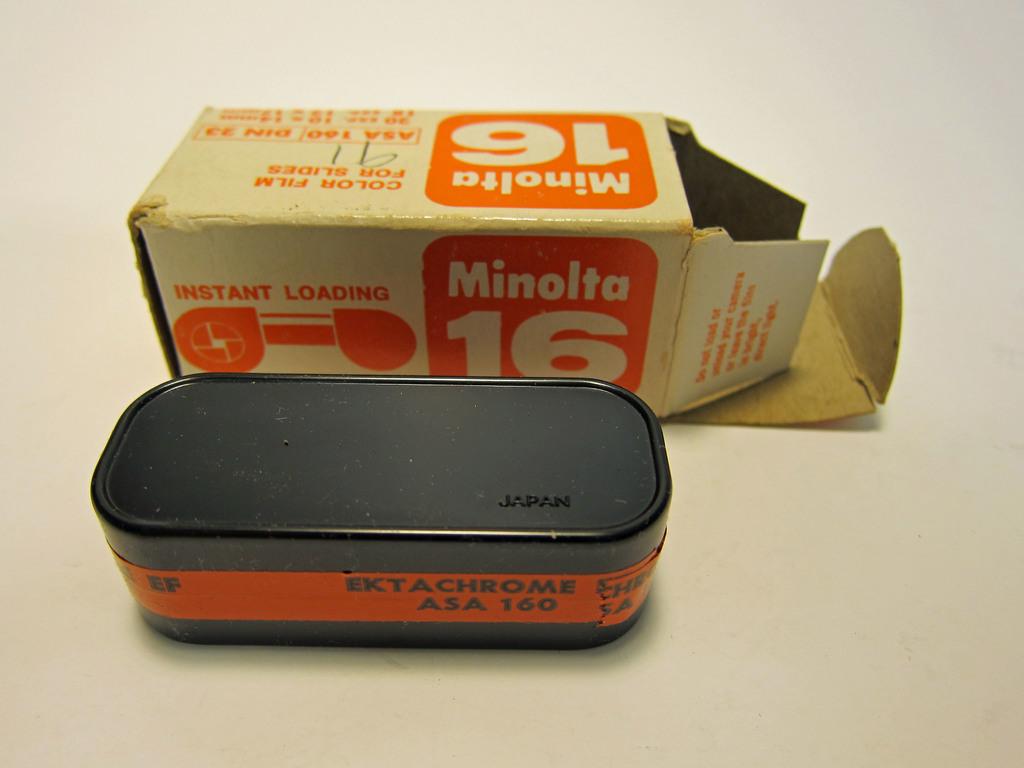What brand of camera is this?
Offer a very short reply. Minolta. What is instant?
Ensure brevity in your answer.  Loading. 